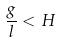<formula> <loc_0><loc_0><loc_500><loc_500>\frac { g } { l } < H</formula> 